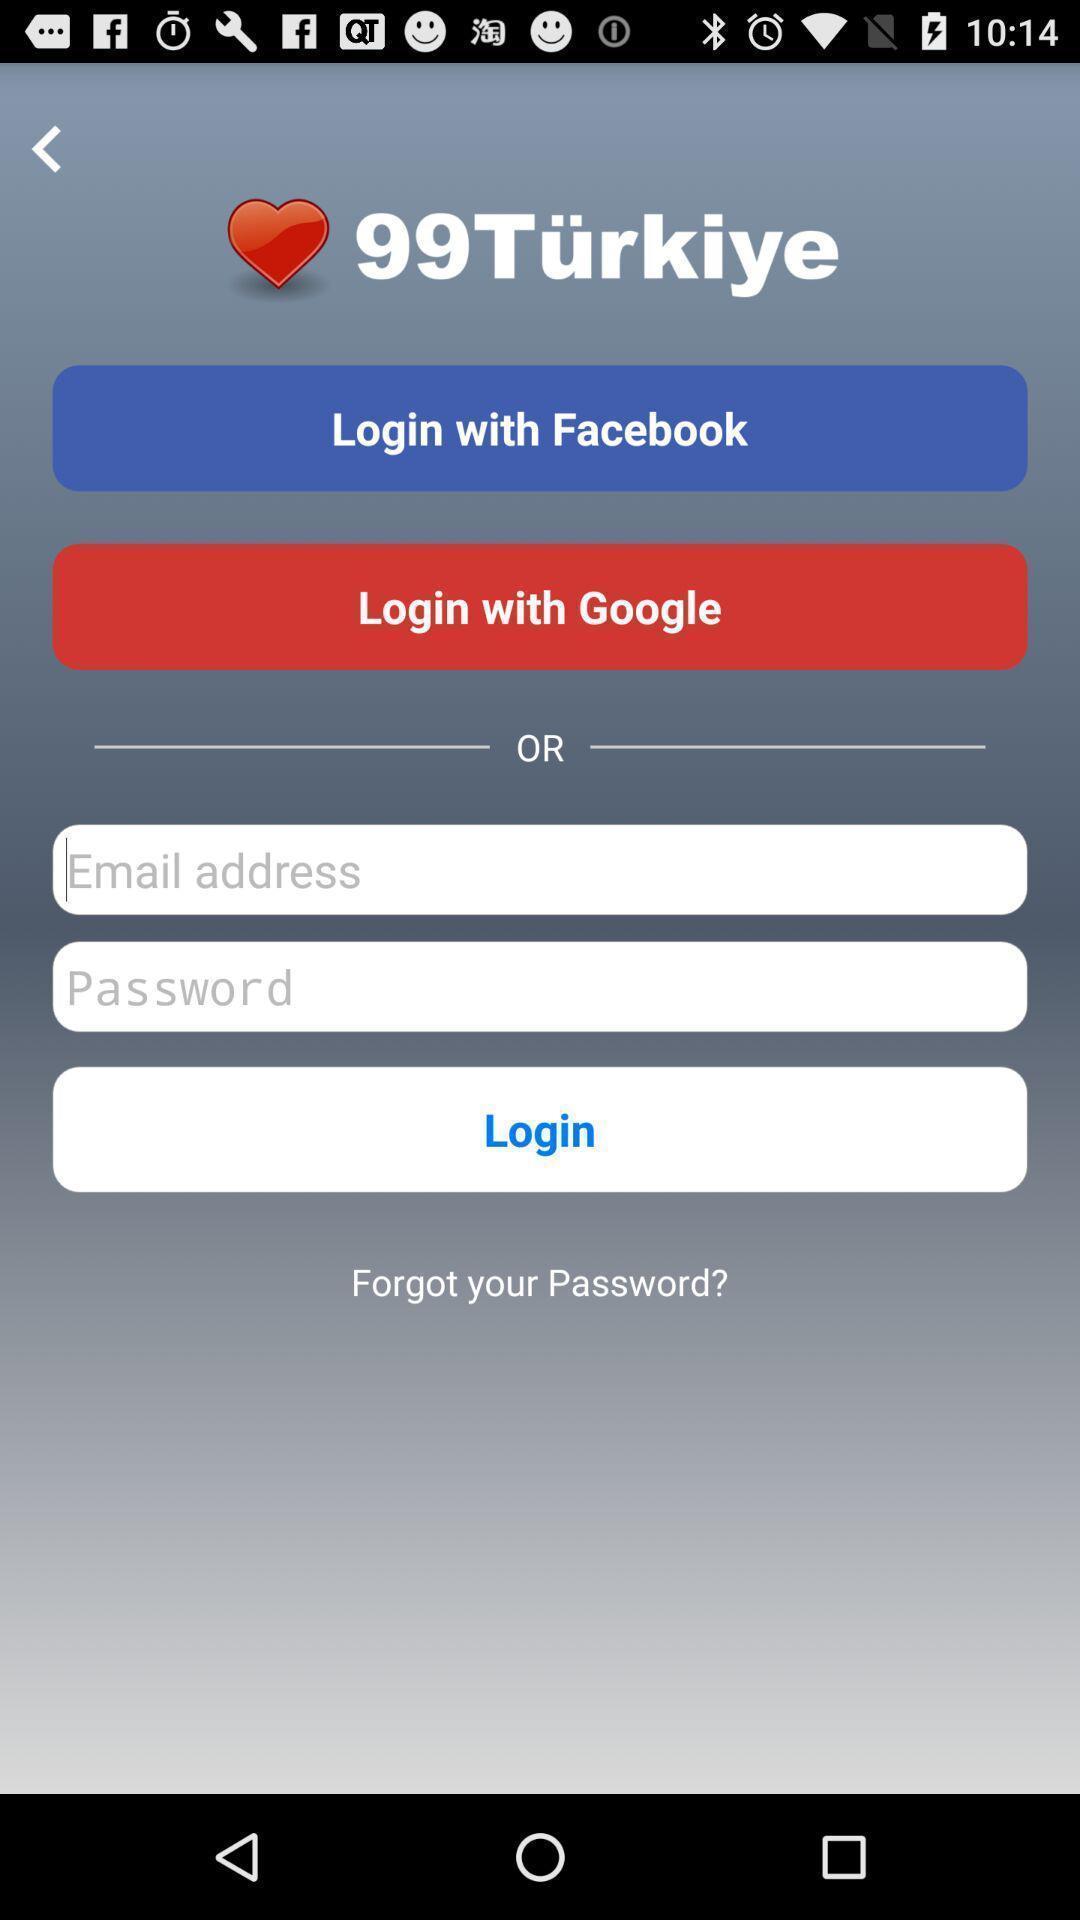Describe the content in this image. Page displaying to enter login credentials. 